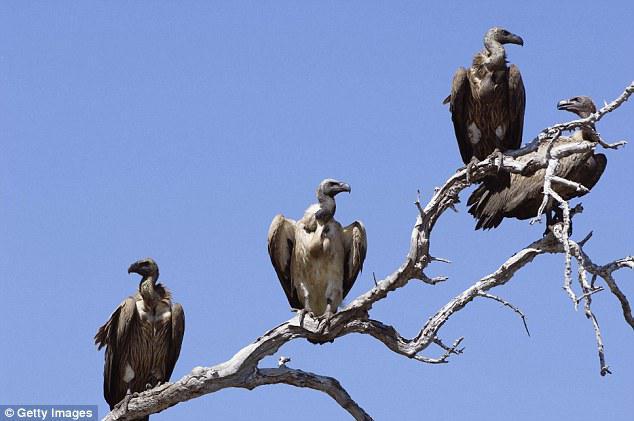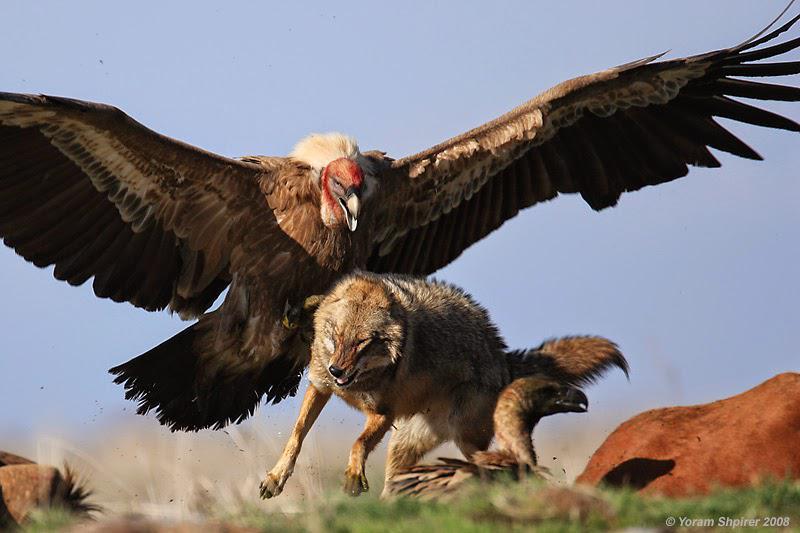The first image is the image on the left, the second image is the image on the right. Examine the images to the left and right. Is the description "Each image includes a vulture with outspread wings, and one image contains a single vulture that is in mid-air." accurate? Answer yes or no. No. The first image is the image on the left, the second image is the image on the right. For the images displayed, is the sentence "One image contains more than four vultures on a tree that is at least mostly bare, and the other contains a single vulture." factually correct? Answer yes or no. Yes. 